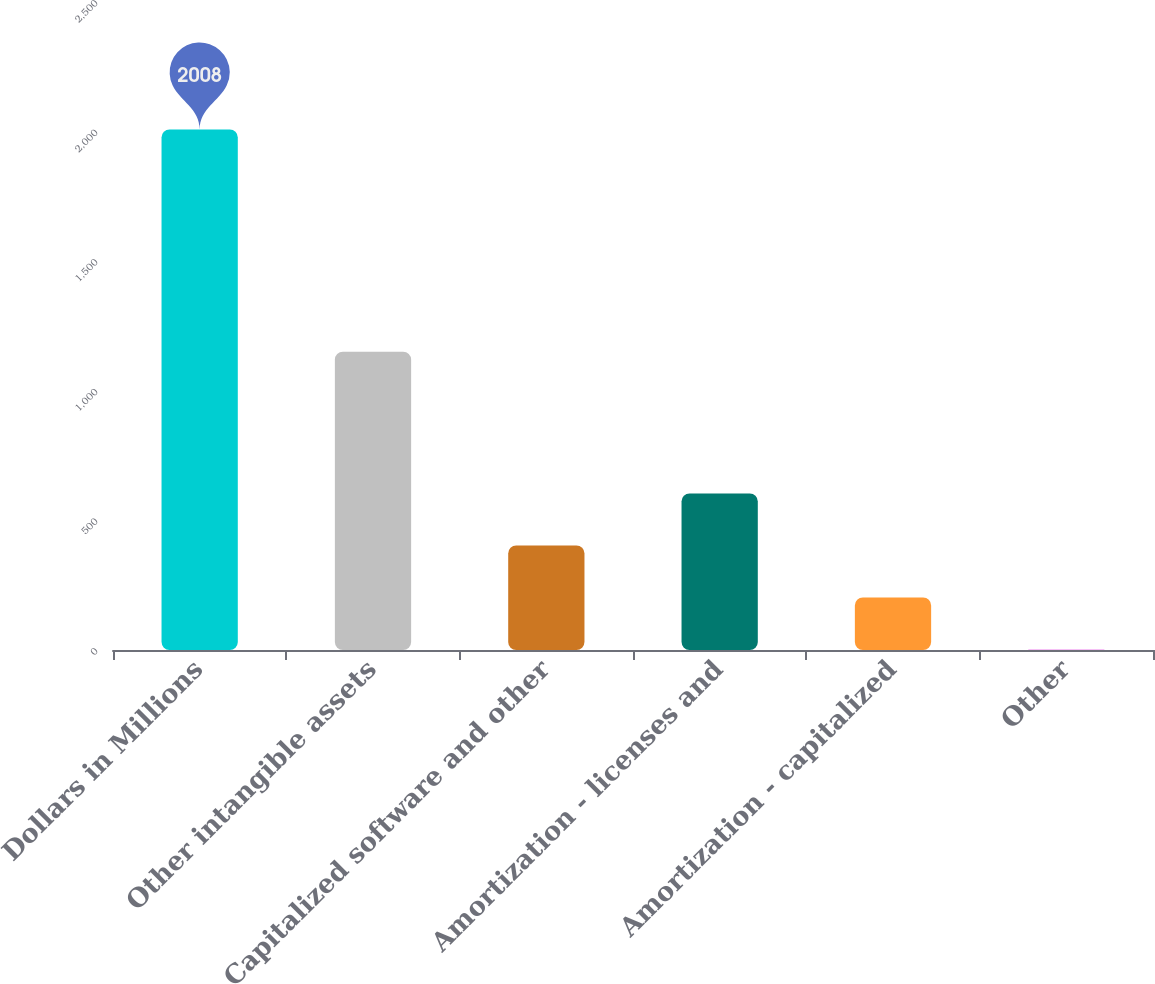Convert chart. <chart><loc_0><loc_0><loc_500><loc_500><bar_chart><fcel>Dollars in Millions<fcel>Other intangible assets<fcel>Capitalized software and other<fcel>Amortization - licenses and<fcel>Amortization - capitalized<fcel>Other<nl><fcel>2008<fcel>1151<fcel>403.2<fcel>603.8<fcel>202.6<fcel>2<nl></chart> 